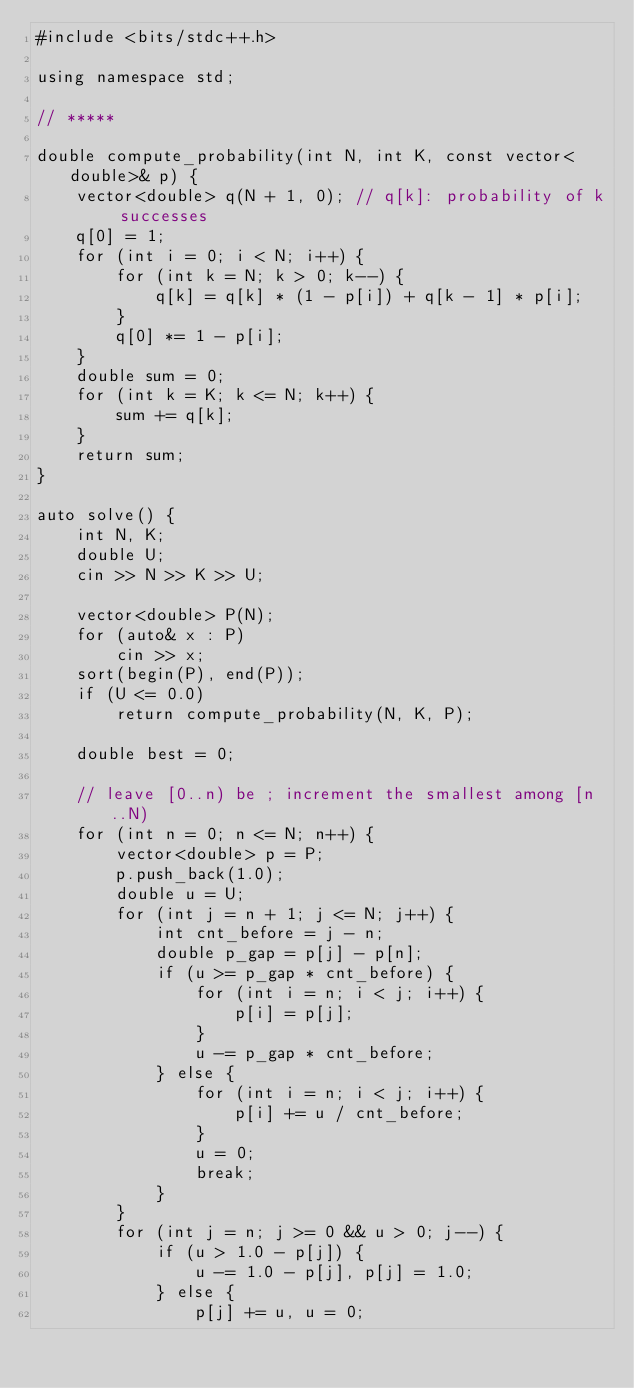<code> <loc_0><loc_0><loc_500><loc_500><_C++_>#include <bits/stdc++.h>

using namespace std;

// *****

double compute_probability(int N, int K, const vector<double>& p) {
    vector<double> q(N + 1, 0); // q[k]: probability of k successes
    q[0] = 1;
    for (int i = 0; i < N; i++) {
        for (int k = N; k > 0; k--) {
            q[k] = q[k] * (1 - p[i]) + q[k - 1] * p[i];
        }
        q[0] *= 1 - p[i];
    }
    double sum = 0;
    for (int k = K; k <= N; k++) {
        sum += q[k];
    }
    return sum;
}

auto solve() {
    int N, K;
    double U;
    cin >> N >> K >> U;

    vector<double> P(N);
    for (auto& x : P)
        cin >> x;
    sort(begin(P), end(P));
    if (U <= 0.0)
        return compute_probability(N, K, P);

    double best = 0;

    // leave [0..n) be ; increment the smallest among [n..N)
    for (int n = 0; n <= N; n++) {
        vector<double> p = P;
        p.push_back(1.0);
        double u = U;
        for (int j = n + 1; j <= N; j++) {
            int cnt_before = j - n;
            double p_gap = p[j] - p[n];
            if (u >= p_gap * cnt_before) {
                for (int i = n; i < j; i++) {
                    p[i] = p[j];
                }
                u -= p_gap * cnt_before;
            } else {
                for (int i = n; i < j; i++) {
                    p[i] += u / cnt_before;
                }
                u = 0;
                break;
            }
        }
        for (int j = n; j >= 0 && u > 0; j--) {
            if (u > 1.0 - p[j]) {
                u -= 1.0 - p[j], p[j] = 1.0;
            } else {
                p[j] += u, u = 0;</code> 